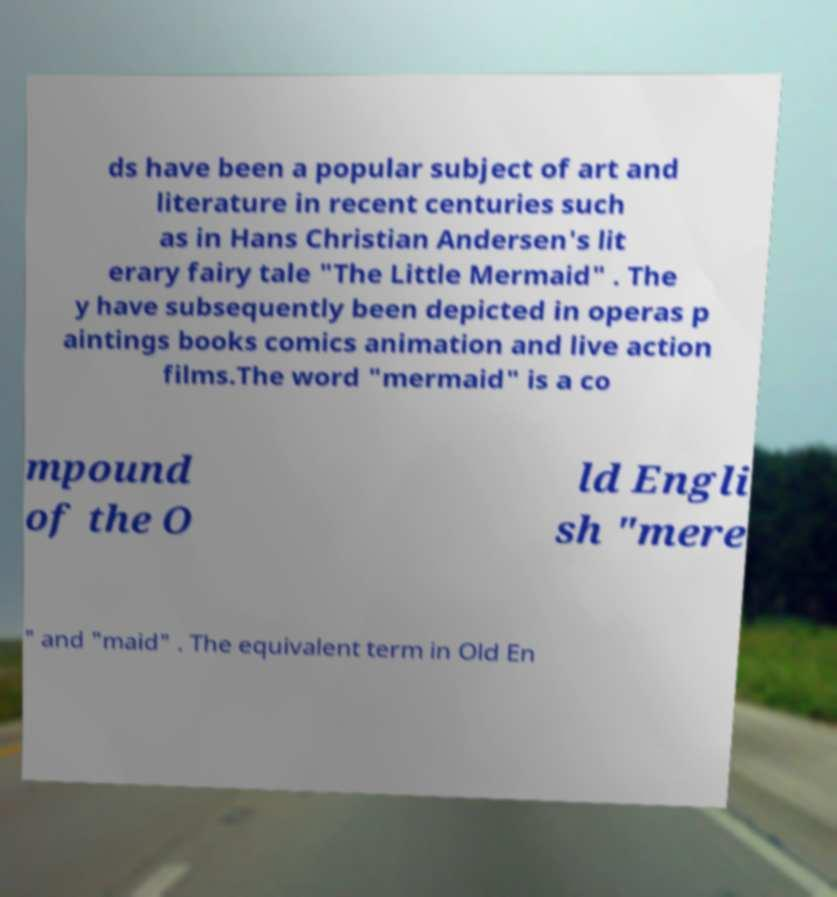For documentation purposes, I need the text within this image transcribed. Could you provide that? ds have been a popular subject of art and literature in recent centuries such as in Hans Christian Andersen's lit erary fairy tale "The Little Mermaid" . The y have subsequently been depicted in operas p aintings books comics animation and live action films.The word "mermaid" is a co mpound of the O ld Engli sh "mere " and "maid" . The equivalent term in Old En 